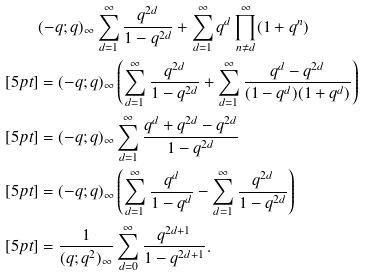Convert formula to latex. <formula><loc_0><loc_0><loc_500><loc_500>& ( - q ; q ) _ { \infty } \sum _ { d = 1 } ^ { \infty } \frac { q ^ { 2 d } } { 1 - q ^ { 2 d } } + \sum _ { d = 1 } ^ { \infty } q ^ { d } \prod _ { n \neq d } ^ { \infty } ( 1 + q ^ { n } ) \\ [ 5 p t ] & = ( - q ; q ) _ { \infty } \left ( \sum _ { d = 1 } ^ { \infty } \frac { q ^ { 2 d } } { 1 - q ^ { 2 d } } + \sum _ { d = 1 } ^ { \infty } \frac { q ^ { d } - q ^ { 2 d } } { ( 1 - q ^ { d } ) ( 1 + q ^ { d } ) } \right ) \\ [ 5 p t ] & = ( - q ; q ) _ { \infty } \sum _ { d = 1 } ^ { \infty } \frac { q ^ { d } + q ^ { 2 d } - q ^ { 2 d } } { 1 - q ^ { 2 d } } \\ [ 5 p t ] & = ( - q ; q ) _ { \infty } \left ( \sum _ { d = 1 } ^ { \infty } \frac { q ^ { d } } { 1 - q ^ { d } } - \sum _ { d = 1 } ^ { \infty } \frac { q ^ { 2 d } } { 1 - q ^ { 2 d } } \right ) \\ [ 5 p t ] & = \frac { 1 } { ( q ; q ^ { 2 } ) _ { \infty } } \sum _ { d = 0 } ^ { \infty } \frac { q ^ { 2 d + 1 } } { 1 - q ^ { 2 d + 1 } } .</formula> 